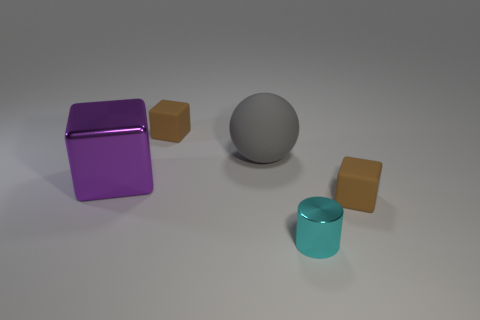What size is the gray matte object that is in front of the small matte cube that is left of the rubber thing that is on the right side of the cyan metallic thing?
Provide a short and direct response. Large. The thing that is to the left of the gray ball and in front of the large sphere has what shape?
Keep it short and to the point. Cube. Are there an equal number of rubber cubes on the right side of the big gray thing and small brown matte objects behind the big block?
Your response must be concise. Yes. Are there any other large spheres made of the same material as the large gray sphere?
Your answer should be very brief. No. Is the material of the brown thing left of the sphere the same as the large sphere?
Your answer should be very brief. Yes. How big is the thing that is behind the tiny cyan cylinder and in front of the purple block?
Provide a succinct answer. Small. What color is the large matte thing?
Ensure brevity in your answer.  Gray. What number of small metallic cylinders are there?
Your answer should be compact. 1. How many large things are the same color as the small metallic thing?
Offer a terse response. 0. There is a metal thing on the left side of the small metallic thing; is it the same shape as the brown matte object behind the large gray thing?
Provide a succinct answer. Yes. 